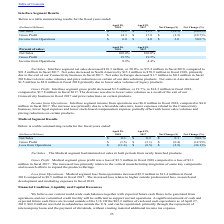According to Methode Electronics's financial document, How much was the Interface segment net sales in fiscal 2018 and 2017? Interface segment net sales decreased $18.3 million, or 20.0%, to $73.2 million in fiscal 2018, compared to $91.5 million in fiscal 2017.. The document states: "Net Sales . Interface segment net sales decreased $18.3 million, or 20.0%, to $73.2 million in fiscal 2018, compared to $91.5 million in fiscal 2017. ..." Also, Why did the Net sales decreased in North America? Net sales decreased in North America by $15.1 million to $70.9 million in fiscal 2018, primarily due to the exit of our Connectivity business in fiscal 2017.. The document states: "$91.5 million in fiscal 2017. Net sales decreased in North America by $15.1 million to $70.9 million in fiscal 2018, primarily due to the exit of our ..." Also, Why did the Net sales decreased in Europe? Net sales in Europe decreased $1.7 million to $0.3 million in fiscal 2018 due to lower sales volumes and price reductions on certain of our data solutions products.. The document states: "exit of our Connectivity business in fiscal 2017. Net sales in Europe decreased $1.7 million to $0.3 million in fiscal 2018 due to lower sales volumes..." Also, can you calculate: What is the average Net Sales for April 29, 2017 to April 28, 2018? To answer this question, I need to perform calculations using the financial data. The calculation is: (73.2+91.5) / 2, which equals 82.35 (in millions). This is based on the information: "Net Sales $ 73.2 $ 91.5 $ (18.3) (20.0)% Net Sales $ 73.2 $ 91.5 $ (18.3) (20.0)%..." The key data points involved are: 73.2, 91.5. Also, can you calculate: What is the average Gross Profit for April 29, 2017 to April 28, 2018? To answer this question, I need to perform calculations using the financial data. The calculation is: (14.3+17.8) / 2, which equals 16.05 (in millions). This is based on the information: "Gross Profit $ 14.3 $ 17.8 $ (3.5) (19.7)% Gross Profit $ 14.3 $ 17.8 $ (3.5) (19.7)%..." The key data points involved are: 14.3, 17.8. Also, can you calculate: What is the average Income from Operations for April 29, 2017 to April 28, 2018? To answer this question, I need to perform calculations using the financial data. The calculation is: (6.0+4.0) / 2, which equals 5 (in millions). This is based on the information: "Income from Operations $ 6.0 $ 4.0 $ 2.0 50.0 % Income from Operations $ 6.0 $ 4.0 $ 2.0 50.0 %..." The key data points involved are: 4.0, 6.0. 